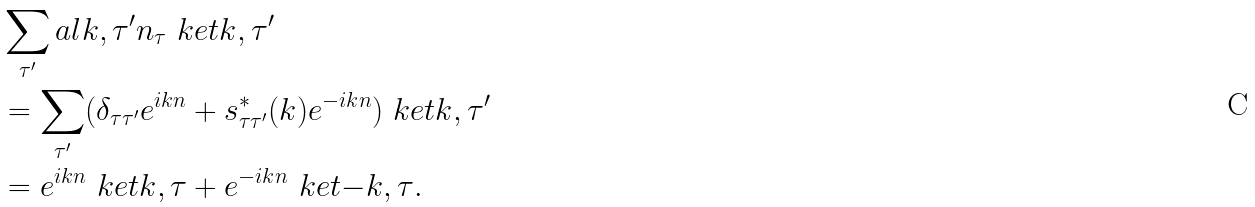<formula> <loc_0><loc_0><loc_500><loc_500>& \sum _ { \tau ^ { \prime } } a l { k , \tau ^ { \prime } } { n _ { \tau } } \ k e t { k , \tau ^ { \prime } } \\ & = \sum _ { \tau ^ { \prime } } ( \delta _ { \tau \tau ^ { \prime } } e ^ { i k n } + s _ { \tau \tau ^ { \prime } } ^ { * } ( k ) e ^ { - i k n } ) \ k e t { k , \tau ^ { \prime } } \\ & = e ^ { i k n } \ k e t { k , \tau } + e ^ { - i k n } \ k e t { - k , \tau } .</formula> 